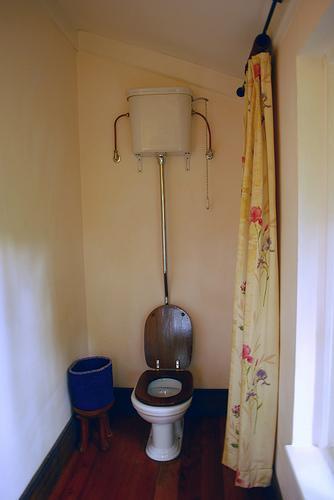How many toilets are there?
Give a very brief answer. 1. 